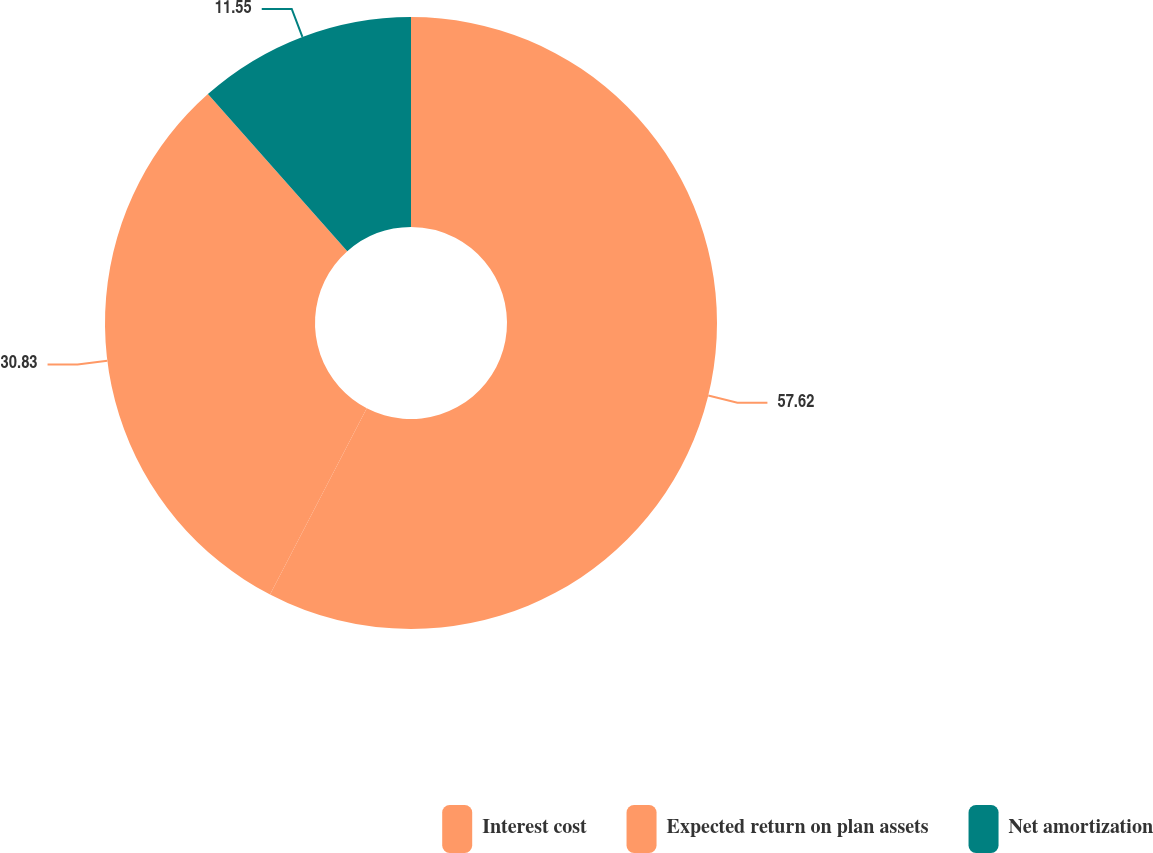<chart> <loc_0><loc_0><loc_500><loc_500><pie_chart><fcel>Interest cost<fcel>Expected return on plan assets<fcel>Net amortization<nl><fcel>57.62%<fcel>30.83%<fcel>11.55%<nl></chart> 